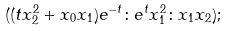<formula> <loc_0><loc_0><loc_500><loc_500>& ( ( t x _ { 2 } ^ { 2 } + x _ { 0 } x _ { 1 } ) e ^ { - t } \colon e ^ { t } x _ { 1 } ^ { 2 } \colon x _ { 1 } x _ { 2 } ) ;</formula> 